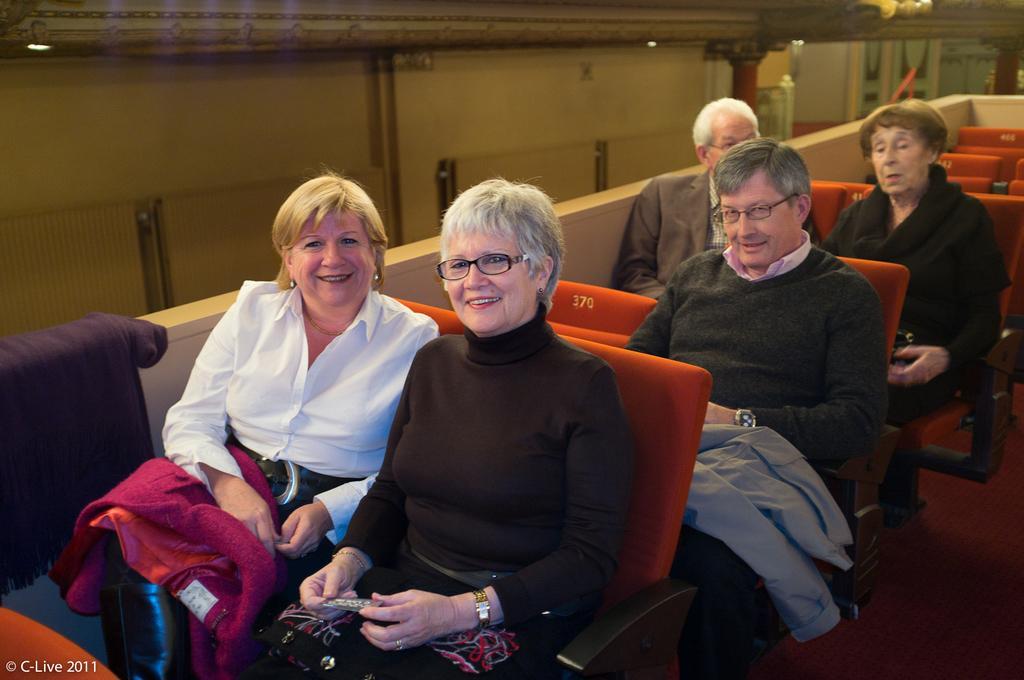In one or two sentences, can you explain what this image depicts? In this image I see 3 women and 2 men who are sitting on chairs and I see few empty chairs over here and I see that these 3 of them are smiling and I see the lights over here and I see that the chairs are of orange in color and I see the wall over here. 